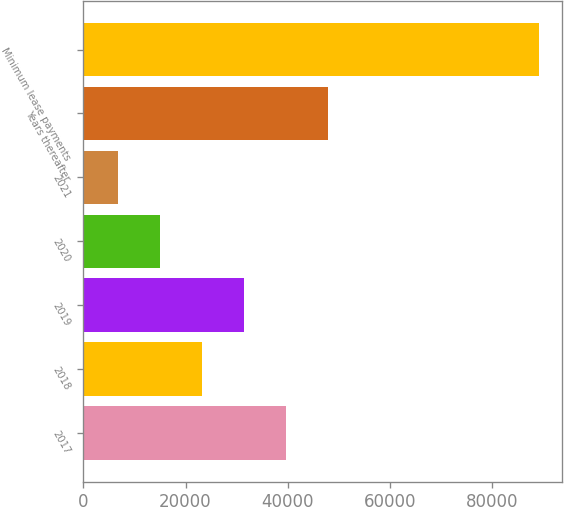<chart> <loc_0><loc_0><loc_500><loc_500><bar_chart><fcel>2017<fcel>2018<fcel>2019<fcel>2020<fcel>2021<fcel>Years thereafter<fcel>Minimum lease payments<nl><fcel>39666.2<fcel>23181.6<fcel>31423.9<fcel>14939.3<fcel>6697<fcel>47908.5<fcel>89120<nl></chart> 